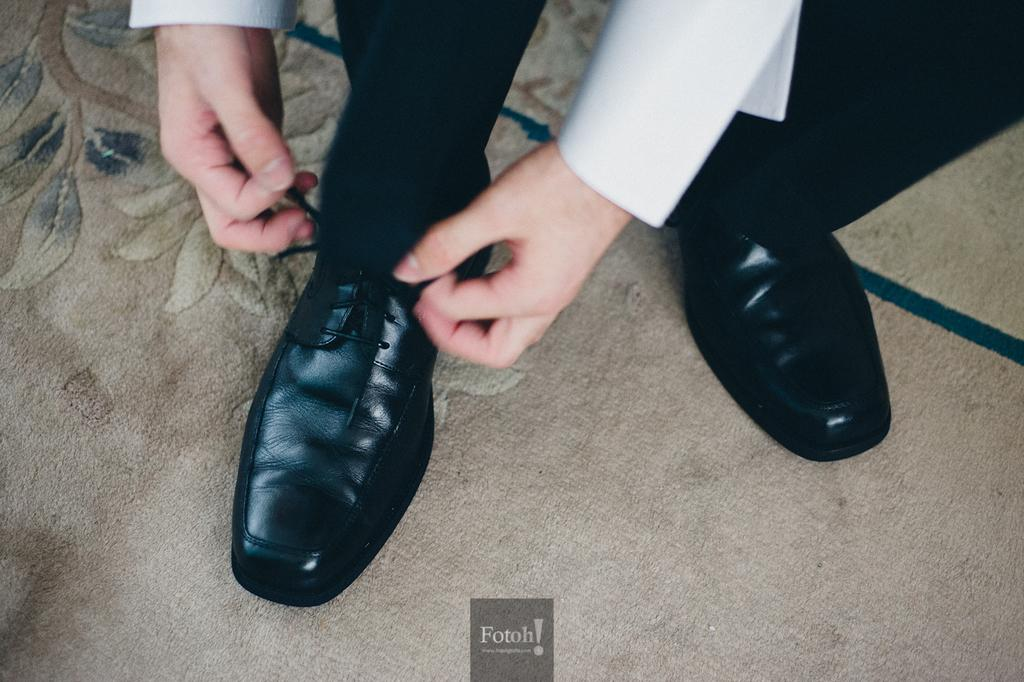What is the main subject of the image? There is a person in the image. What is the person doing in the image? The person's hands are tying shoelaces. What color are the shoes the person is wearing? The shoes are black. What is at the bottom of the image? There is a mat at the bottom of the image. How does the person taste the connection with their uncle in the image? There is no mention of a connection or an uncle in the image; it only shows a person tying their shoelaces. 